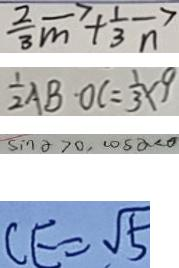Convert formula to latex. <formula><loc_0><loc_0><loc_500><loc_500>\frac { 2 } { 3 } \overrightarrow { m } + \frac { 1 } { 3 } \overrightarrow { n } 
 \frac { 1 } { 2 } A B \cdot O C = \frac { 1 } { 3 } \times 9 
 \sin x > 0 , \cos x < 0 
 C E = \sqrt { 5 }</formula> 